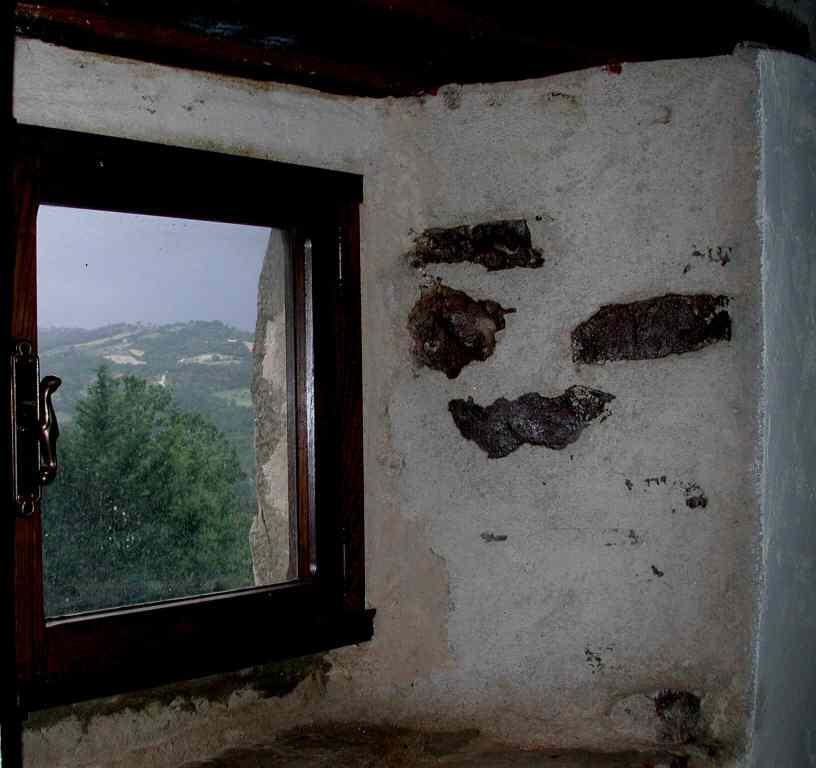How would you summarize this image in a sentence or two? In this picture, we see a white wall. On the left side, we see a glass window from which we can see trees and hills. We even see the sky. 